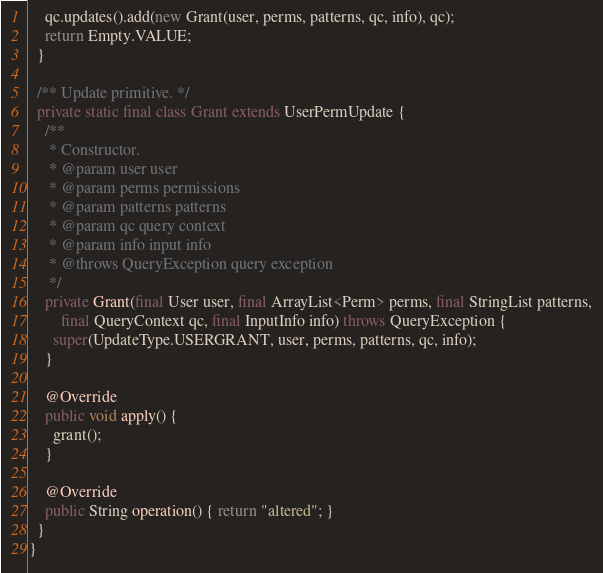Convert code to text. <code><loc_0><loc_0><loc_500><loc_500><_Java_>
    qc.updates().add(new Grant(user, perms, patterns, qc, info), qc);
    return Empty.VALUE;
  }

  /** Update primitive. */
  private static final class Grant extends UserPermUpdate {
    /**
     * Constructor.
     * @param user user
     * @param perms permissions
     * @param patterns patterns
     * @param qc query context
     * @param info input info
     * @throws QueryException query exception
     */
    private Grant(final User user, final ArrayList<Perm> perms, final StringList patterns,
        final QueryContext qc, final InputInfo info) throws QueryException {
      super(UpdateType.USERGRANT, user, perms, patterns, qc, info);
    }

    @Override
    public void apply() {
      grant();
    }

    @Override
    public String operation() { return "altered"; }
  }
}
</code> 